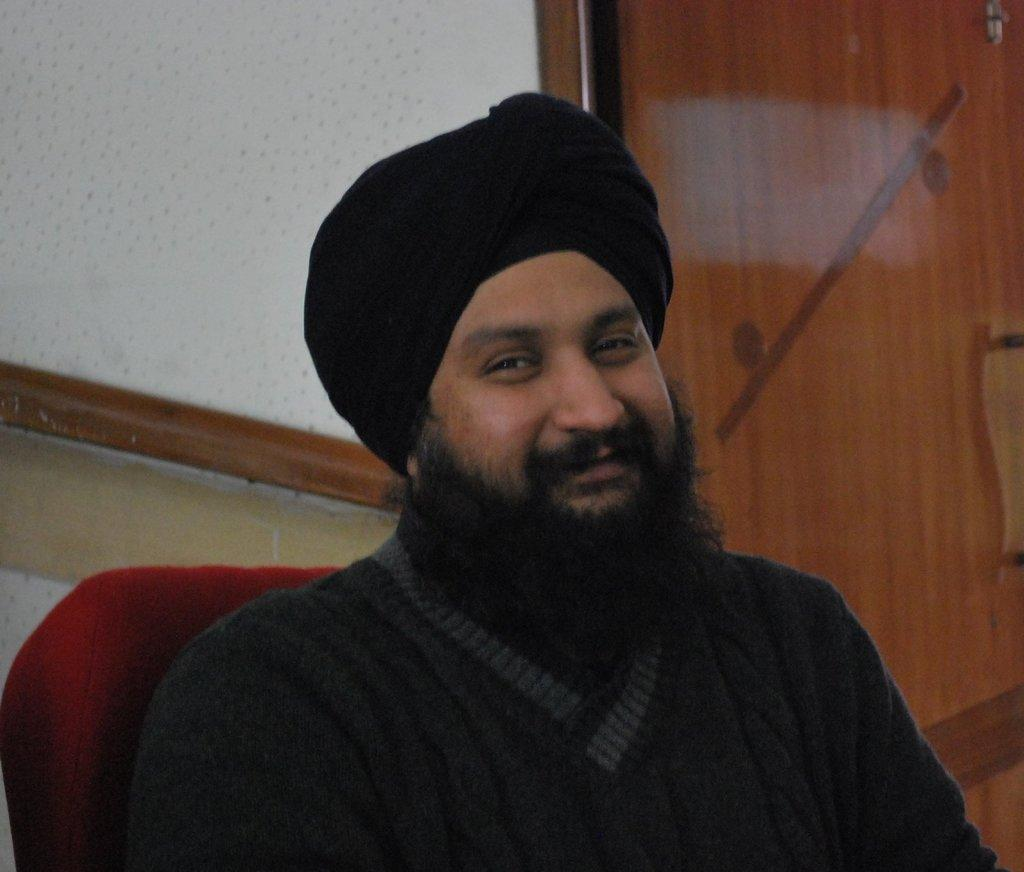Who is in the image? There is a person in the image. What is the person doing in the image? The person is sitting on a chair and posing for a photo. What is the person wearing in the image? The person is wearing a black dress. What can be seen in the background of the image? There is a door visible in the background of the image. What is the price of the tray in the image? There is no tray present in the image, so it is not possible to determine its price. 